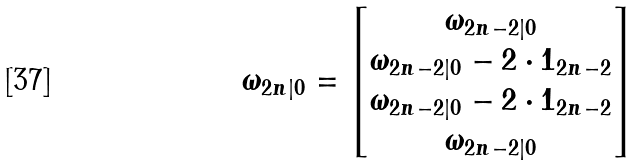<formula> <loc_0><loc_0><loc_500><loc_500>\omega _ { 2 n | 0 } = \begin{bmatrix} \omega _ { 2 n - 2 | 0 } \\ \omega _ { 2 n - 2 | 0 } - 2 \cdot 1 _ { 2 n - 2 } \\ \omega _ { 2 n - 2 | 0 } - 2 \cdot 1 _ { 2 n - 2 } \\ \omega _ { 2 n - 2 | 0 } \end{bmatrix}</formula> 